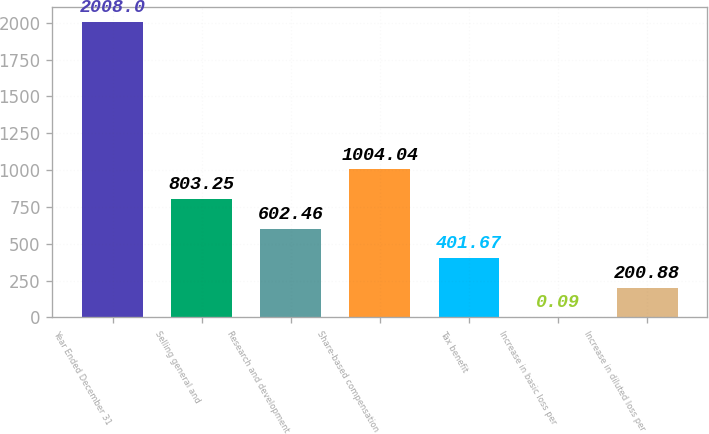Convert chart. <chart><loc_0><loc_0><loc_500><loc_500><bar_chart><fcel>Year Ended December 31<fcel>Selling general and<fcel>Research and development<fcel>Share-based compensation<fcel>Tax benefit<fcel>Increase in basic loss per<fcel>Increase in diluted loss per<nl><fcel>2008<fcel>803.25<fcel>602.46<fcel>1004.04<fcel>401.67<fcel>0.09<fcel>200.88<nl></chart> 